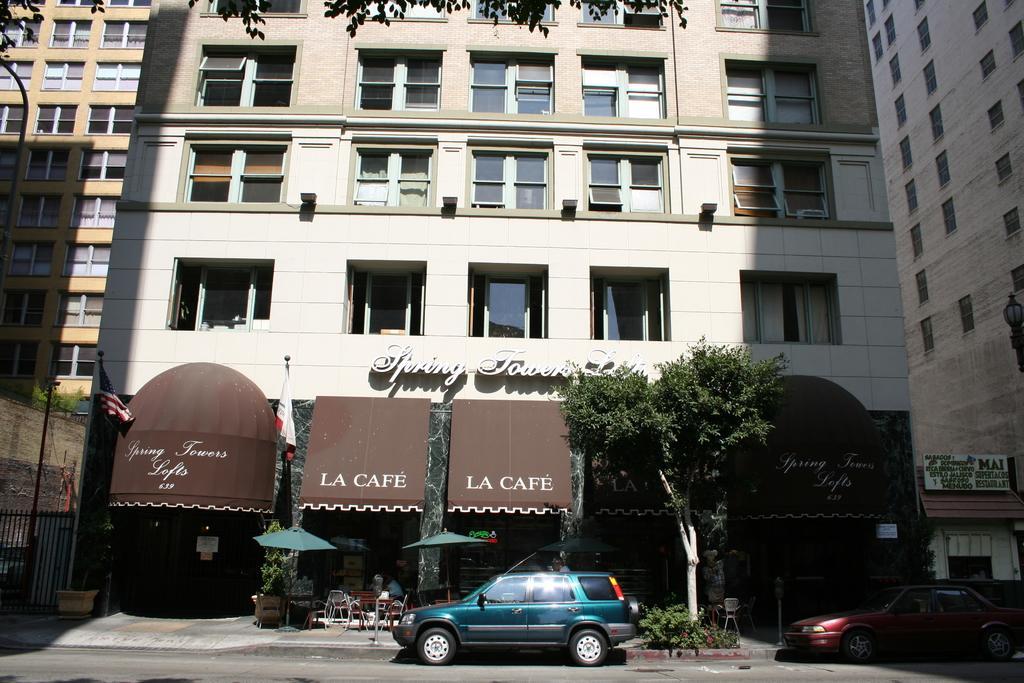In one or two sentences, can you explain what this image depicts? As we can see in the image there are buildings, trees, umbrellas, chairs, plants and cars. 